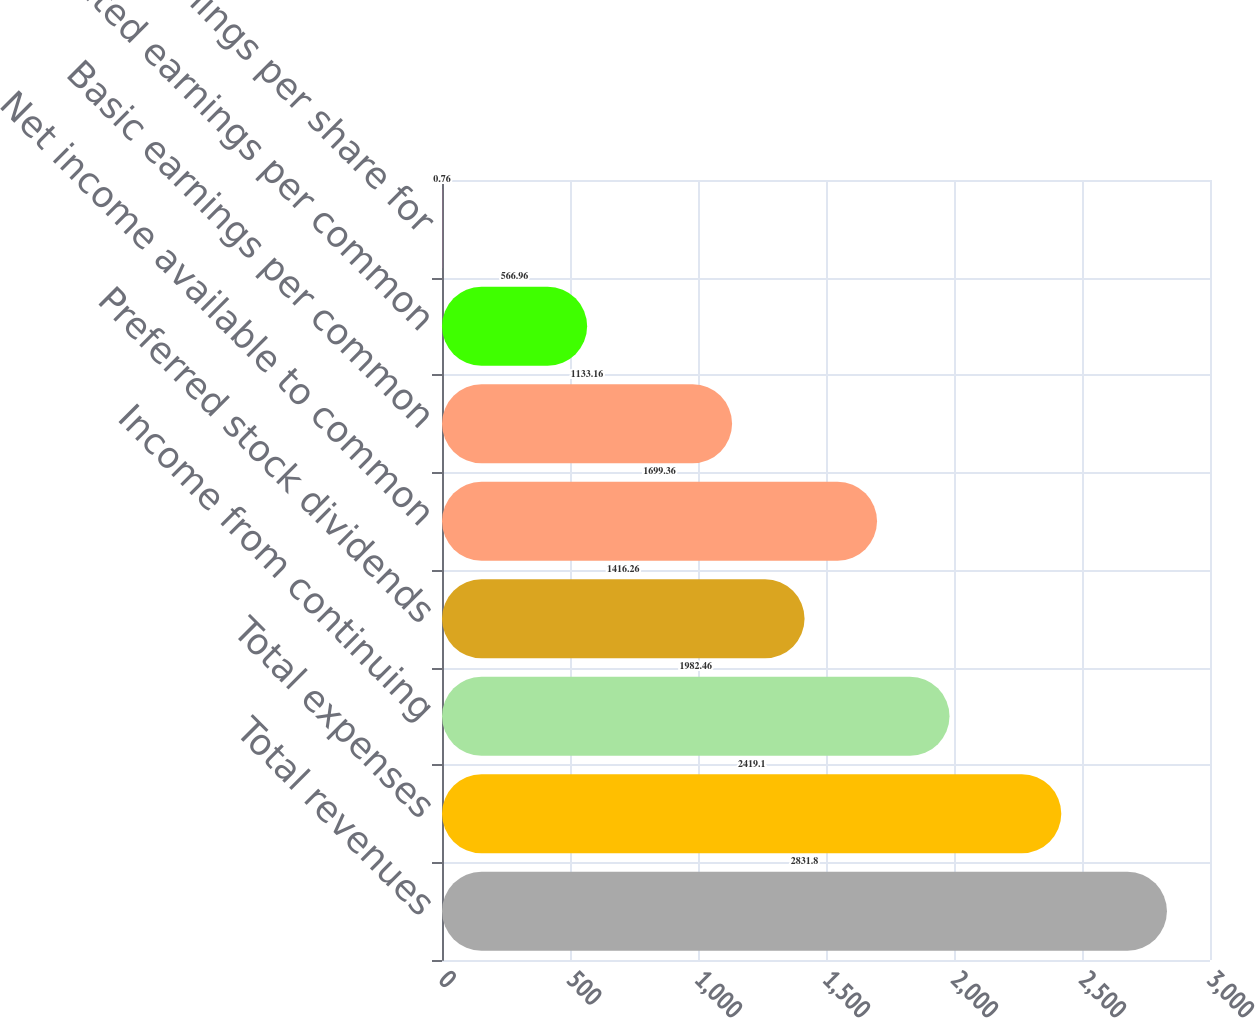<chart> <loc_0><loc_0><loc_500><loc_500><bar_chart><fcel>Total revenues<fcel>Total expenses<fcel>Income from continuing<fcel>Preferred stock dividends<fcel>Net income available to common<fcel>Basic earnings per common<fcel>Diluted earnings per common<fcel>Diluted earnings per share for<nl><fcel>2831.8<fcel>2419.1<fcel>1982.46<fcel>1416.26<fcel>1699.36<fcel>1133.16<fcel>566.96<fcel>0.76<nl></chart> 